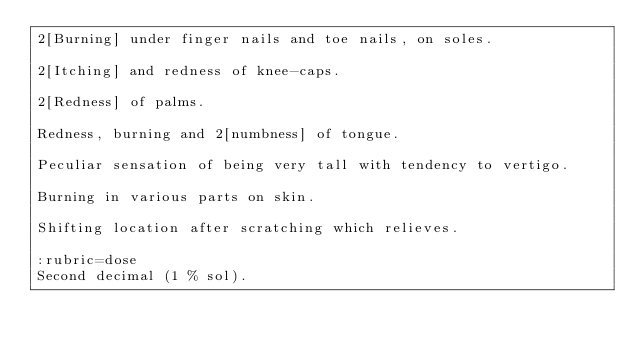Convert code to text. <code><loc_0><loc_0><loc_500><loc_500><_ObjectiveC_>2[Burning] under finger nails and toe nails, on soles.

2[Itching] and redness of knee-caps.

2[Redness] of palms.

Redness, burning and 2[numbness] of tongue.

Peculiar sensation of being very tall with tendency to vertigo.

Burning in various parts on skin.

Shifting location after scratching which relieves.

:rubric=dose
Second decimal (1 % sol).

</code> 